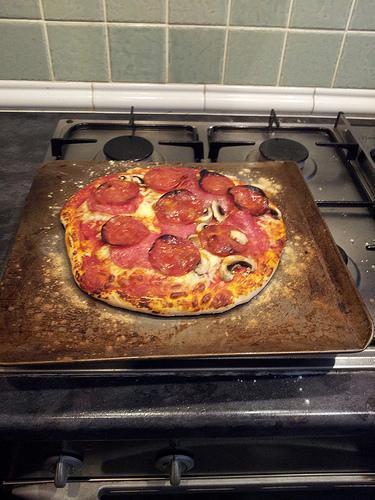How many pizzas are there?
Give a very brief answer. 1. 